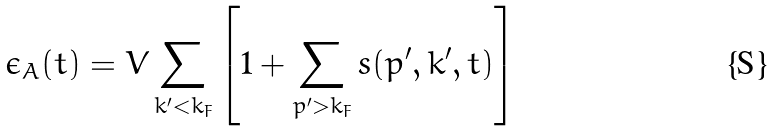<formula> <loc_0><loc_0><loc_500><loc_500>\epsilon _ { A } ( t ) = V \sum _ { k ^ { \prime } < k _ { F } } \left [ 1 + \sum _ { p ^ { \prime } > k _ { F } } s ( { p ^ { \prime } , k ^ { \prime } } , t ) \right ]</formula> 